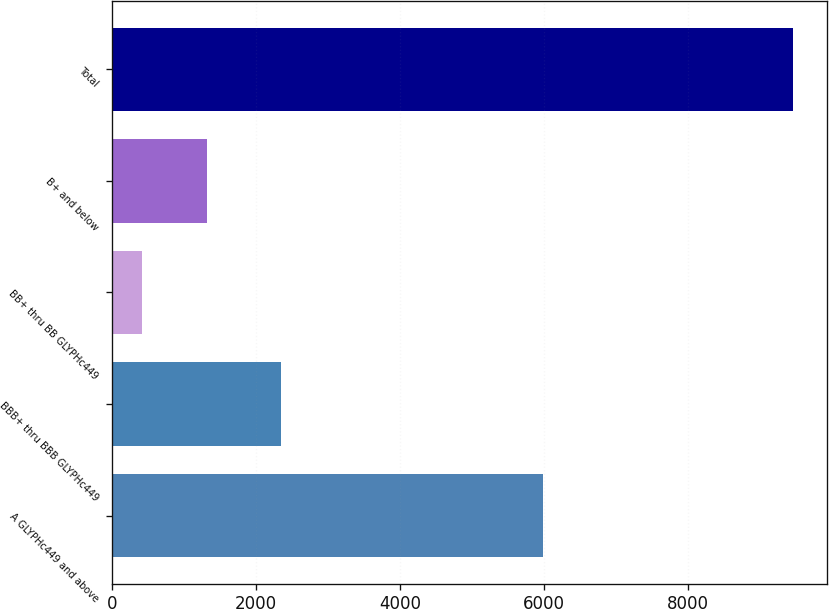<chart> <loc_0><loc_0><loc_500><loc_500><bar_chart><fcel>A GLYPHc449 and above<fcel>BBB+ thru BBB GLYPHc449<fcel>BB+ thru BB GLYPHc449<fcel>B+ and below<fcel>Total<nl><fcel>5991.1<fcel>2351.1<fcel>420.1<fcel>1324.23<fcel>9461.4<nl></chart> 